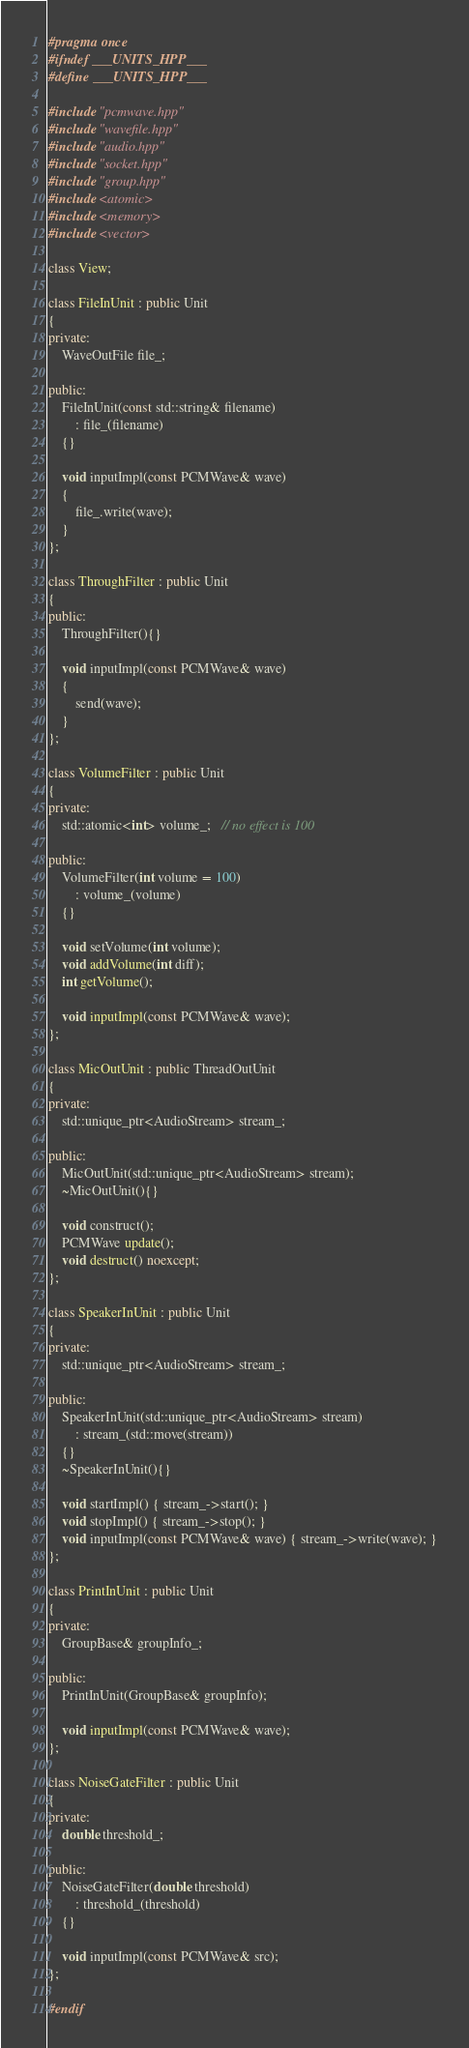Convert code to text. <code><loc_0><loc_0><loc_500><loc_500><_C++_>#pragma once
#ifndef ___UNITS_HPP___
#define ___UNITS_HPP___

#include "pcmwave.hpp"
#include "wavefile.hpp"
#include "audio.hpp"
#include "socket.hpp"
#include "group.hpp"
#include <atomic>
#include <memory>
#include <vector>

class View;

class FileInUnit : public Unit
{
private:
    WaveOutFile file_;

public:
    FileInUnit(const std::string& filename)
        : file_(filename)
    {}

    void inputImpl(const PCMWave& wave)
    {
        file_.write(wave);
    }
};

class ThroughFilter : public Unit
{
public:
    ThroughFilter(){}

    void inputImpl(const PCMWave& wave)
    {
        send(wave);
    }
};

class VolumeFilter : public Unit
{
private:
    std::atomic<int> volume_;   // no effect is 100

public:
    VolumeFilter(int volume = 100)
        : volume_(volume)
    {}

    void setVolume(int volume);
    void addVolume(int diff);
    int getVolume();

    void inputImpl(const PCMWave& wave);
};

class MicOutUnit : public ThreadOutUnit
{
private:
    std::unique_ptr<AudioStream> stream_;

public:
    MicOutUnit(std::unique_ptr<AudioStream> stream);
    ~MicOutUnit(){}

    void construct();
    PCMWave update();
    void destruct() noexcept;
};

class SpeakerInUnit : public Unit
{
private:
    std::unique_ptr<AudioStream> stream_;

public:
    SpeakerInUnit(std::unique_ptr<AudioStream> stream)
        : stream_(std::move(stream))
    {}
    ~SpeakerInUnit(){}

    void startImpl() { stream_->start(); }
    void stopImpl() { stream_->stop(); }
    void inputImpl(const PCMWave& wave) { stream_->write(wave); }
};

class PrintInUnit : public Unit
{
private:
    GroupBase& groupInfo_;

public:
	PrintInUnit(GroupBase& groupInfo);

	void inputImpl(const PCMWave& wave);
};

class NoiseGateFilter : public Unit
{
private:
    double threshold_;

public:
    NoiseGateFilter(double threshold)
        : threshold_(threshold)
    {}

    void inputImpl(const PCMWave& src);
};

#endif
</code> 